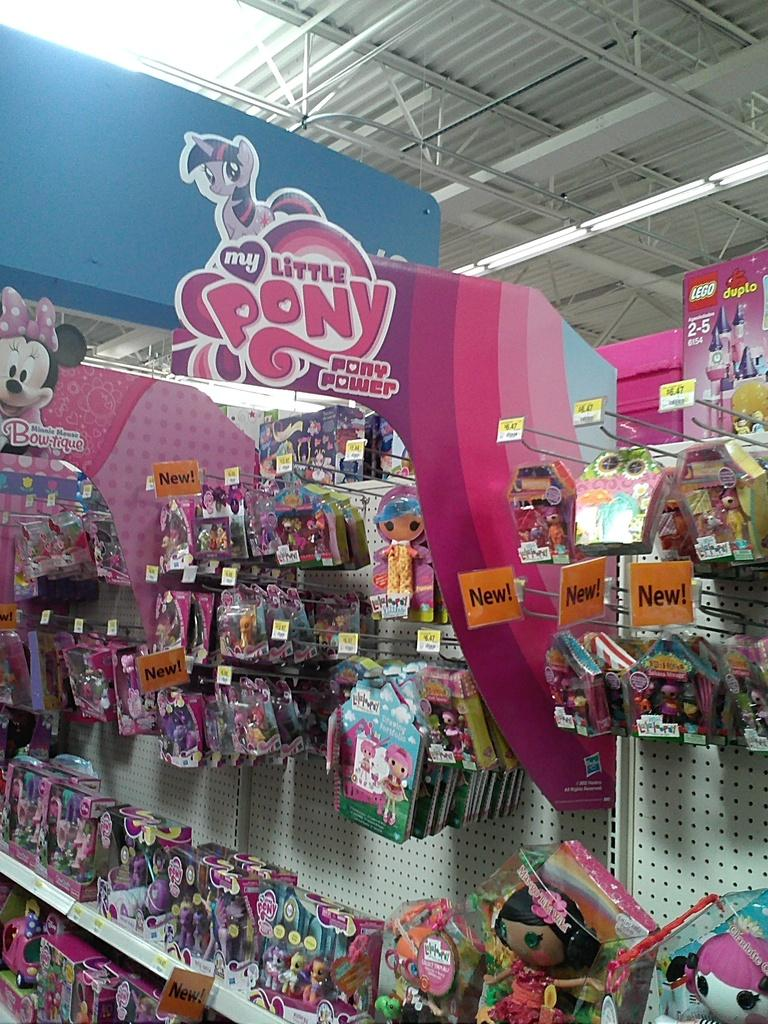<image>
Give a short and clear explanation of the subsequent image. A large collection of My Little pony toys in a aisle. 